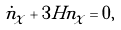<formula> <loc_0><loc_0><loc_500><loc_500>\dot { n } _ { \chi } + 3 H n _ { \chi } = 0 ,</formula> 